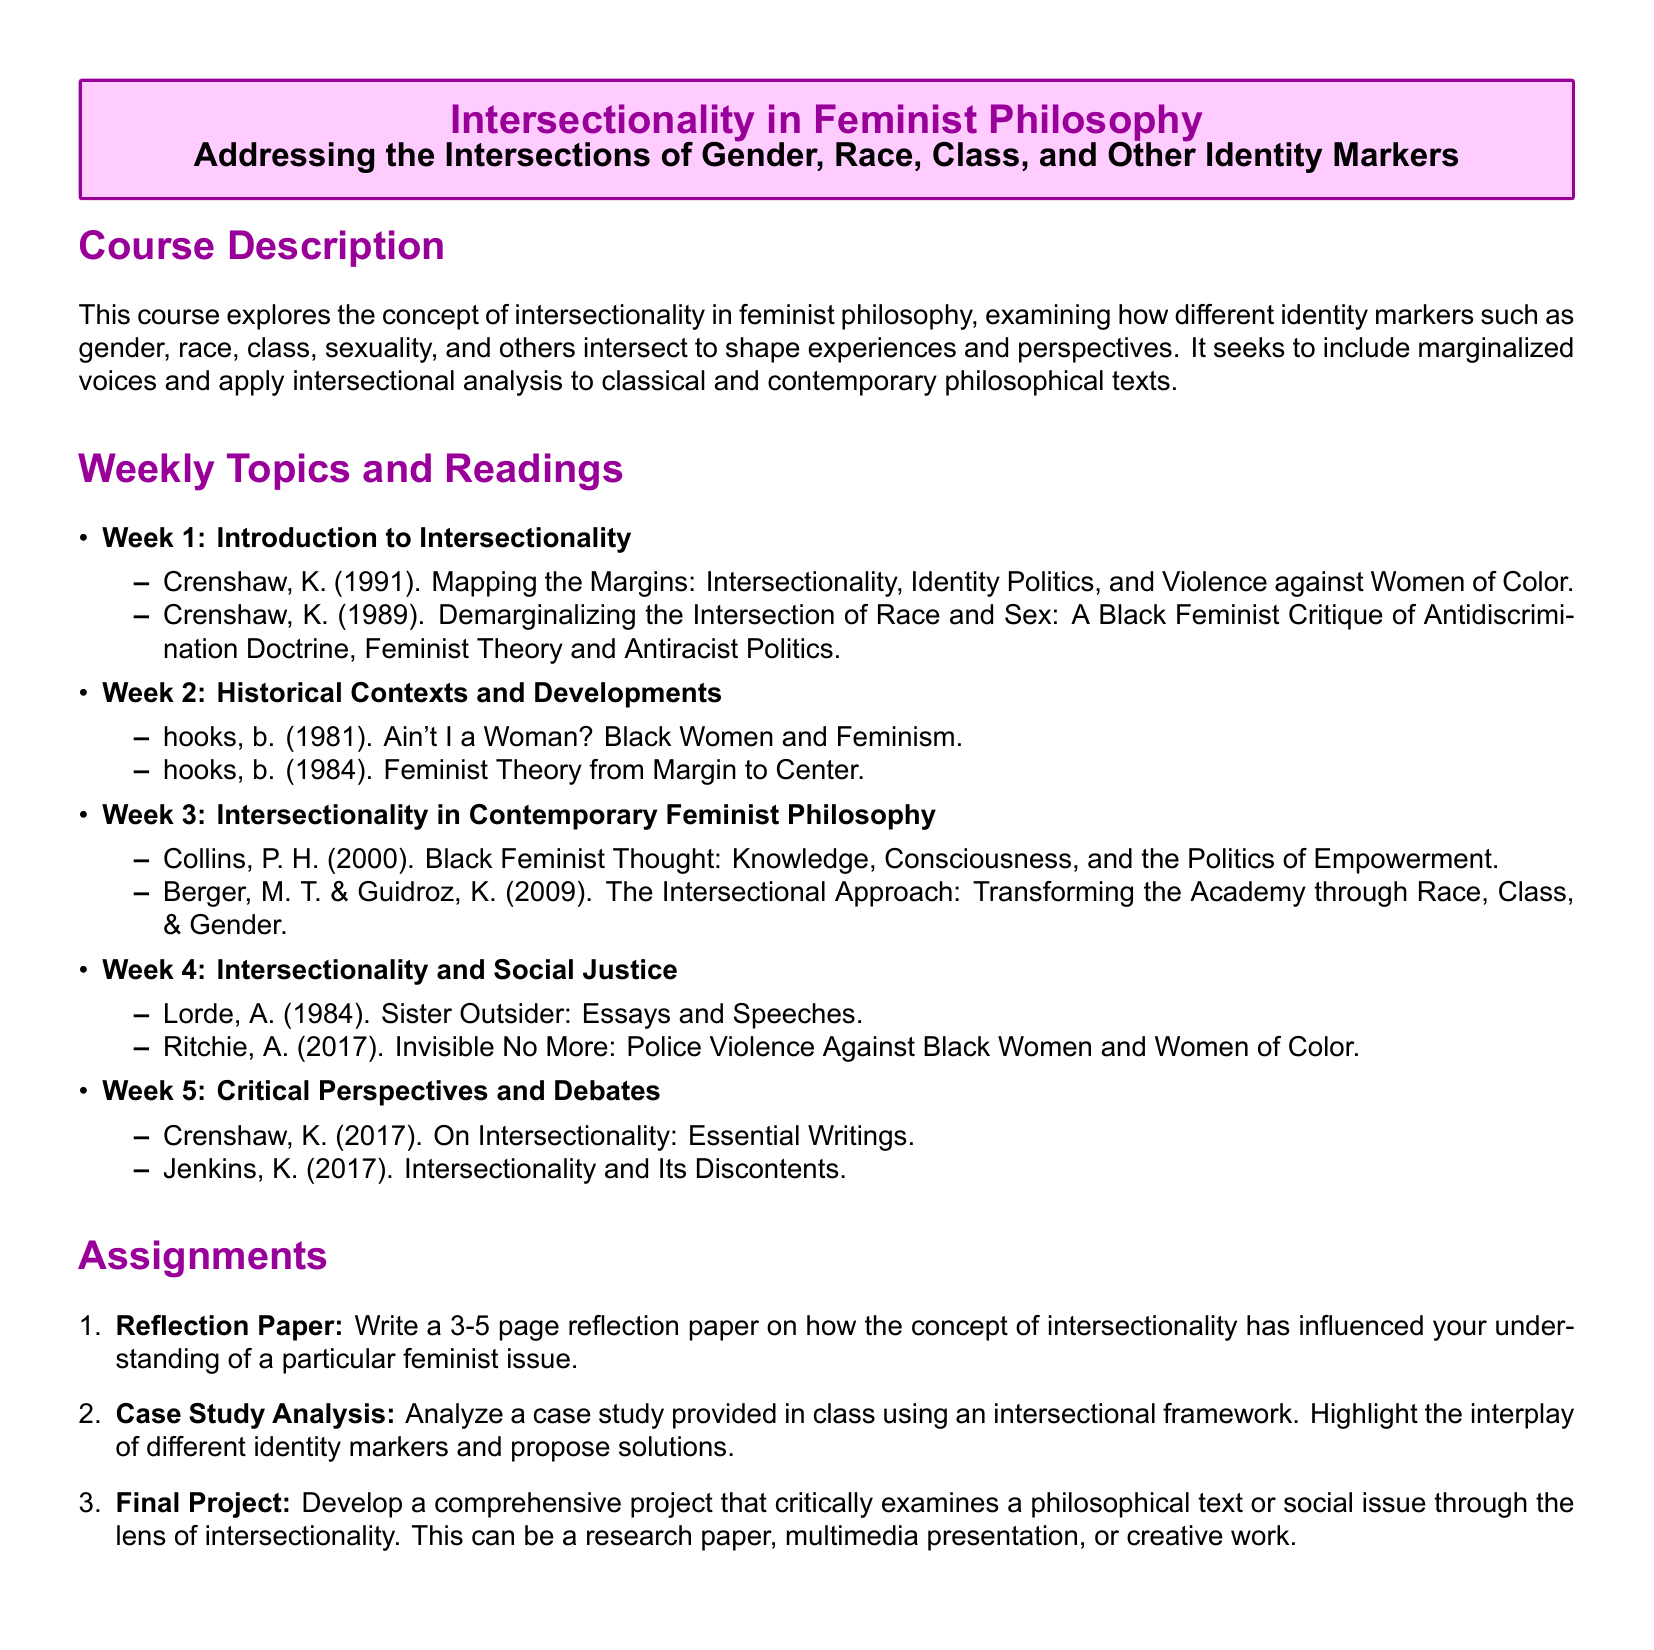What is the title of the course? The title is explicitly stated in the document, which is "Intersectionality in Feminist Philosophy."
Answer: Intersectionality in Feminist Philosophy Who is one of the authors featured in Week 1 readings? The syllabus lists specific authors alongside their works for each week; a notable author for Week 1 is Kimberlé Crenshaw.
Answer: Kimberlé Crenshaw What is the focus of Week 4's readings? The readings for Week 4 center around social justice issues as related to intersectionality.
Answer: Social Justice How long should the reflection paper be? The assignment section specifies the required length of the reflection paper.
Answer: 3-5 pages Which book by bell hooks is included in Week 2? The syllabus lists specific works by each author for the relevant week; one such work by bell hooks is mentioned for Week 2.
Answer: Ain't I a Woman? What is one outcome expected from the case study analysis? The syllabus aims for students to analyze the case and highlight the interplay of different identity markers.
Answer: Interplay of identity markers How many weeks of reading materials are outlined in the syllabus? The outline specified in the document indicates a specific number of weeks.
Answer: 5 weeks What type of project is included in the final assignment? The final project allows for various formats, indicating that options are provided for the student's output.
Answer: Comprehensive project 